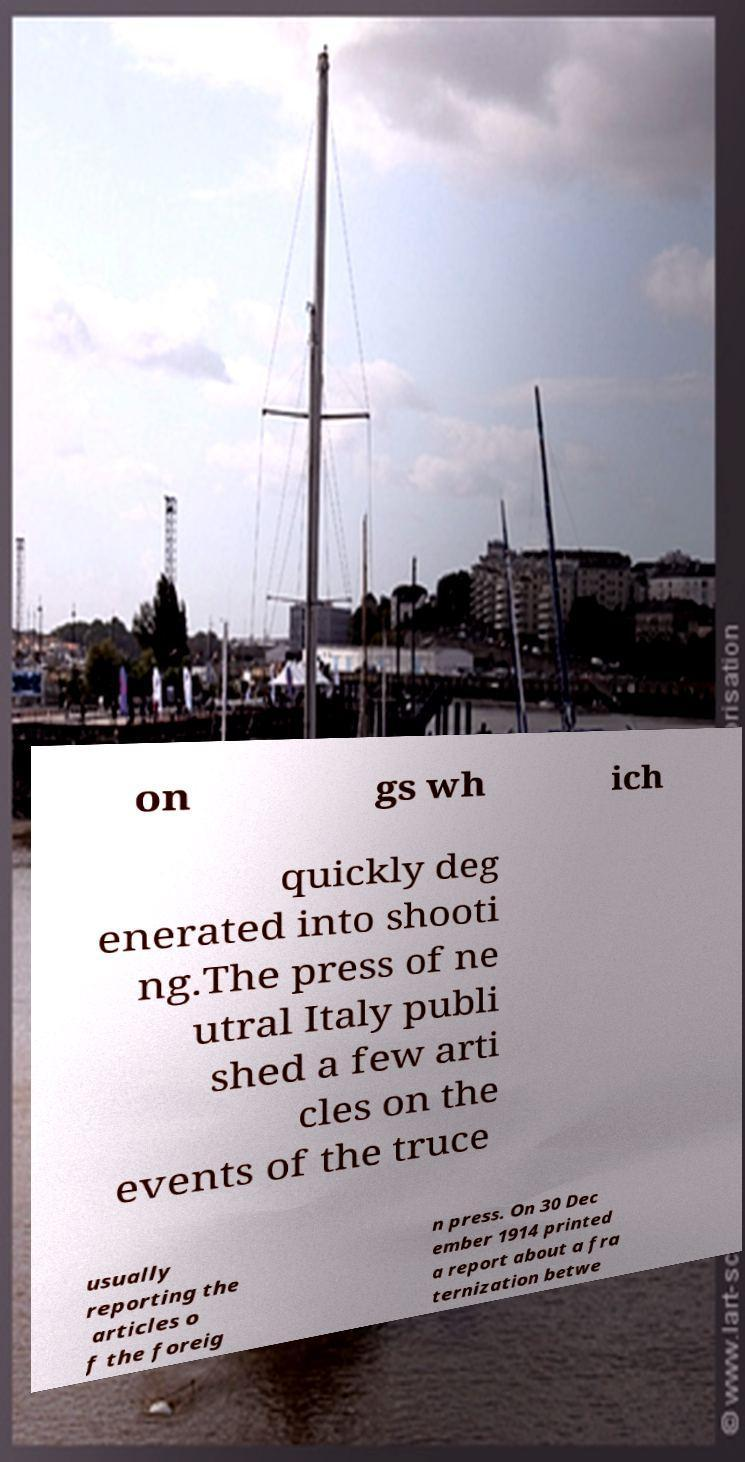Can you read and provide the text displayed in the image?This photo seems to have some interesting text. Can you extract and type it out for me? on gs wh ich quickly deg enerated into shooti ng.The press of ne utral Italy publi shed a few arti cles on the events of the truce usually reporting the articles o f the foreig n press. On 30 Dec ember 1914 printed a report about a fra ternization betwe 